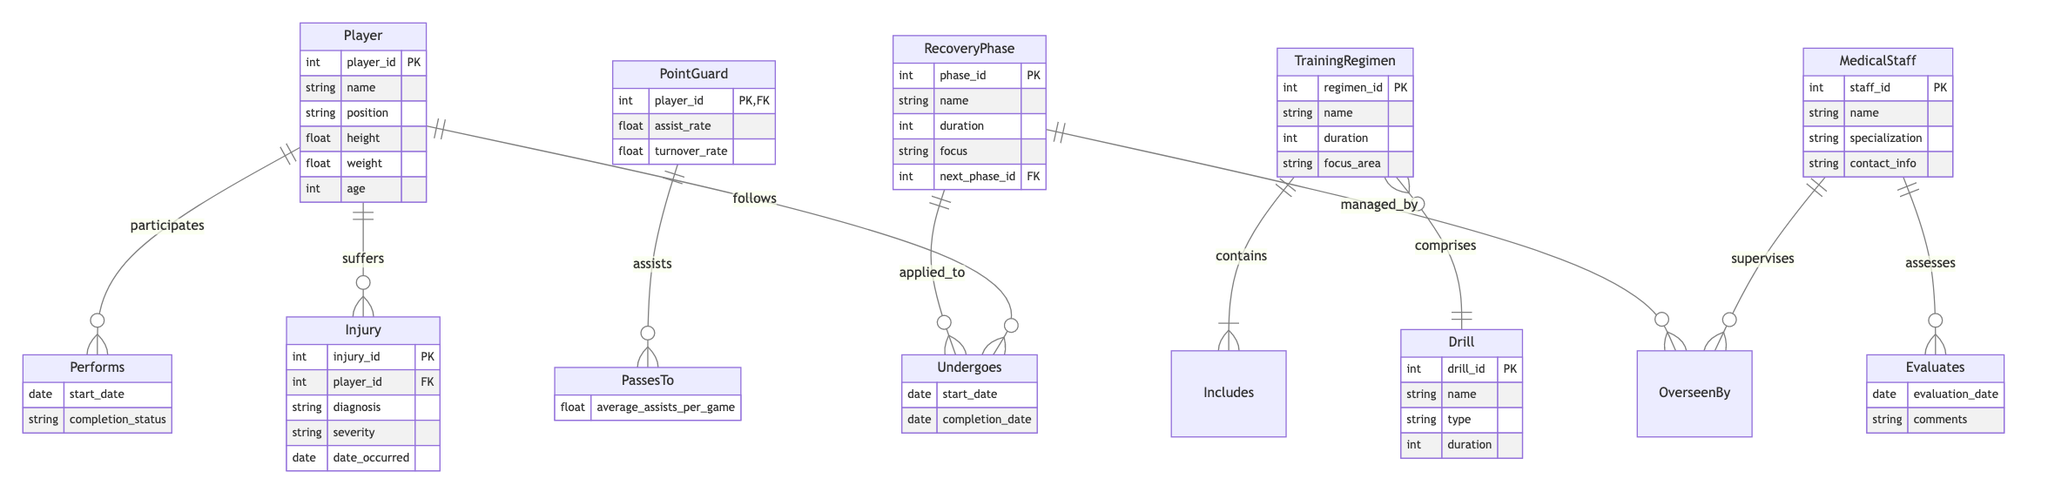What is the primary key of the Player entity? The Player entity's primary key is player_id. This can be determined by looking at the Player entity section where it is designated as "PK," indicating that it is the unique identifier for players.
Answer: player_id How many attributes does the Injury entity have? The Injury entity is described to have five attributes: injury_id, player_id, diagnosis, severity, and date_occurred. Counting these gives a total of five attributes, which can be found in the lists under the Injury entity in the diagram.
Answer: 5 What relationship connects RecoveryPhase and MedicalStaff? The relationship that connects RecoveryPhase and MedicalStaff is "OverseenBy." This is indicated in the relationships section where it explicitly states that RecoveryPhase is managed by MedicalStaff.
Answer: OverseenBy Which entity is most closely related to the PointGuard entity through a relationship? The entity most closely related to the PointGuard entity is Player, as indicated by the "PassesTo" relationship that shows that a PointGuard assists players. We can identify this relationship directly from the relationships section.
Answer: Player What is the focus area of the TrainingRegimen entity? The focus area of the TrainingRegimen entity is specified within its attributes, but as an inquiry, this would depend on individual training regimens available in the dataset. Without specific data, we cannot pinpoint a focus area.
Answer: Varies per regimen Which relationship has an attribute for completion status? The relationship "Performs" includes the attribute for completion status. This is highlighted in the relationship attributes section of the diagram, indicating what information is tracked for this specific relationship.
Answer: Performs How many drills can a TrainingRegimen include? A TrainingRegimen can include multiple drills, as indicated by the "Includes" relationship. The asterisk notation in the relationship suggests that a single TrainingRegimen can correspond to many drills.
Answer: Many What is evaluated by MedicalStaff? MedicalStaff evaluates Players, which is clear from the "Evaluates" relationship listed in the relationships section of the diagram. This indicates that the medical staff's role includes assessing players.
Answer: Players How many recovery phases might a Player undergo? The Player can undergo multiple RecoveryPhase instances as implied by the "Undergoes" relationship. This suggests that each player can be in various phases of recovery at different times, without a maximum specified.
Answer: Multiple 